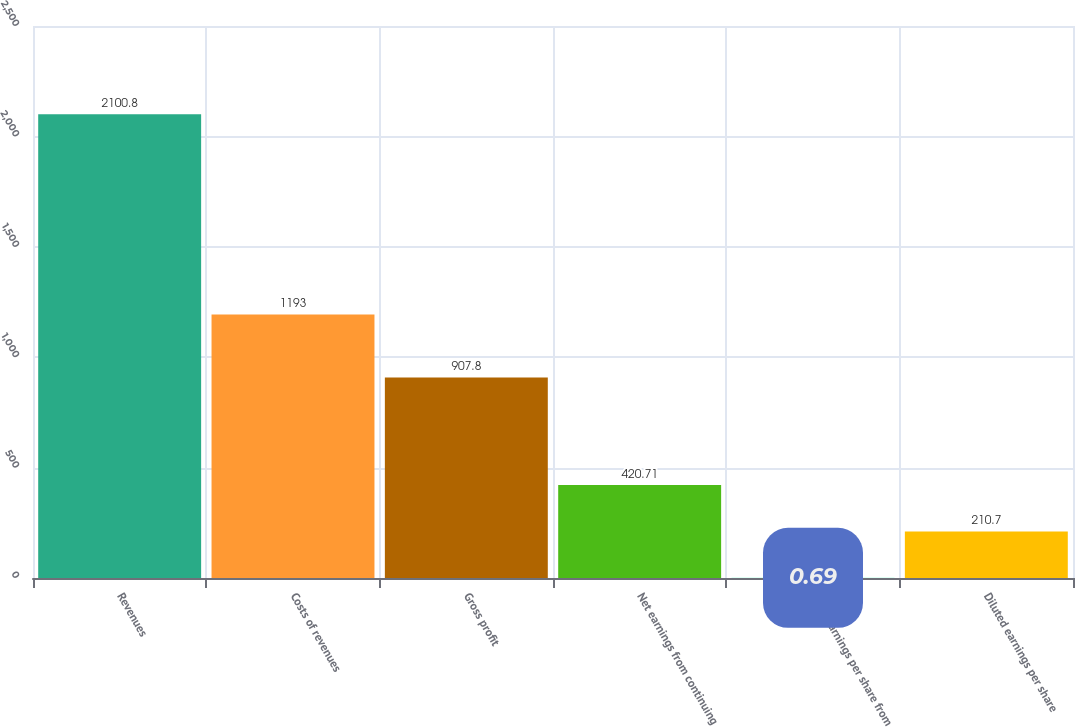Convert chart to OTSL. <chart><loc_0><loc_0><loc_500><loc_500><bar_chart><fcel>Revenues<fcel>Costs of revenues<fcel>Gross profit<fcel>Net earnings from continuing<fcel>Basic earnings per share from<fcel>Diluted earnings per share<nl><fcel>2100.8<fcel>1193<fcel>907.8<fcel>420.71<fcel>0.69<fcel>210.7<nl></chart> 